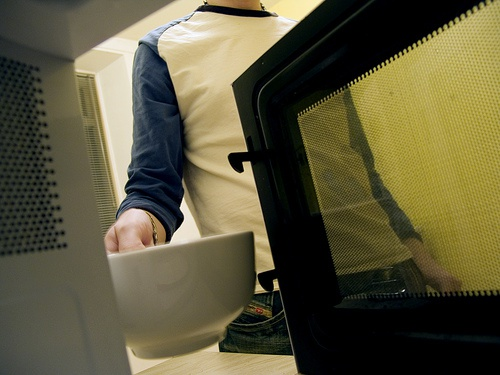Describe the objects in this image and their specific colors. I can see microwave in black, tan, and olive tones, people in black, olive, and tan tones, and bowl in black, gray, and darkgreen tones in this image. 